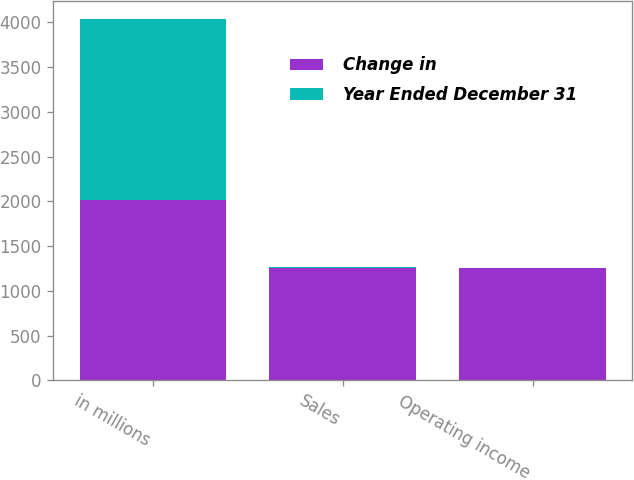Convert chart. <chart><loc_0><loc_0><loc_500><loc_500><stacked_bar_chart><ecel><fcel>in millions<fcel>Sales<fcel>Operating income<nl><fcel>Change in<fcel>2017<fcel>1259<fcel>1259<nl><fcel>Year Ended December 31<fcel>2017<fcel>10<fcel>2<nl></chart> 